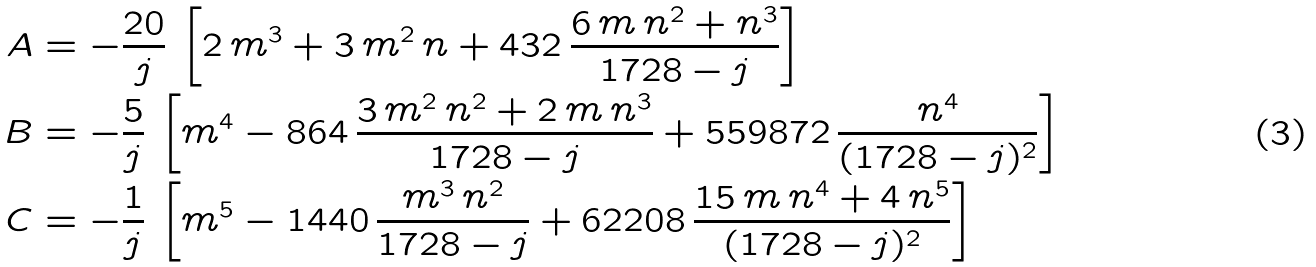Convert formula to latex. <formula><loc_0><loc_0><loc_500><loc_500>A & = - \frac { 2 0 } { j } \, \left [ 2 \, m ^ { 3 } + 3 \, m ^ { 2 } \, n + 4 3 2 \, \frac { 6 \, m \, n ^ { 2 } + n ^ { 3 } } { 1 7 2 8 - j } \right ] \\ B & = - \frac { 5 } { j } \, \left [ m ^ { 4 } - 8 6 4 \, \frac { 3 \, m ^ { 2 } \, n ^ { 2 } + 2 \, m \, n ^ { 3 } } { 1 7 2 8 - j } + 5 5 9 8 7 2 \, \frac { n ^ { 4 } } { ( 1 7 2 8 - j ) ^ { 2 } } \right ] \\ C & = - \frac { 1 } { j } \, \left [ m ^ { 5 } - 1 4 4 0 \, \frac { m ^ { 3 } \, n ^ { 2 } } { 1 7 2 8 - j } + 6 2 2 0 8 \, \frac { 1 5 \, m \, n ^ { 4 } + 4 \, n ^ { 5 } } { ( 1 7 2 8 - j ) ^ { 2 } } \right ] \\</formula> 